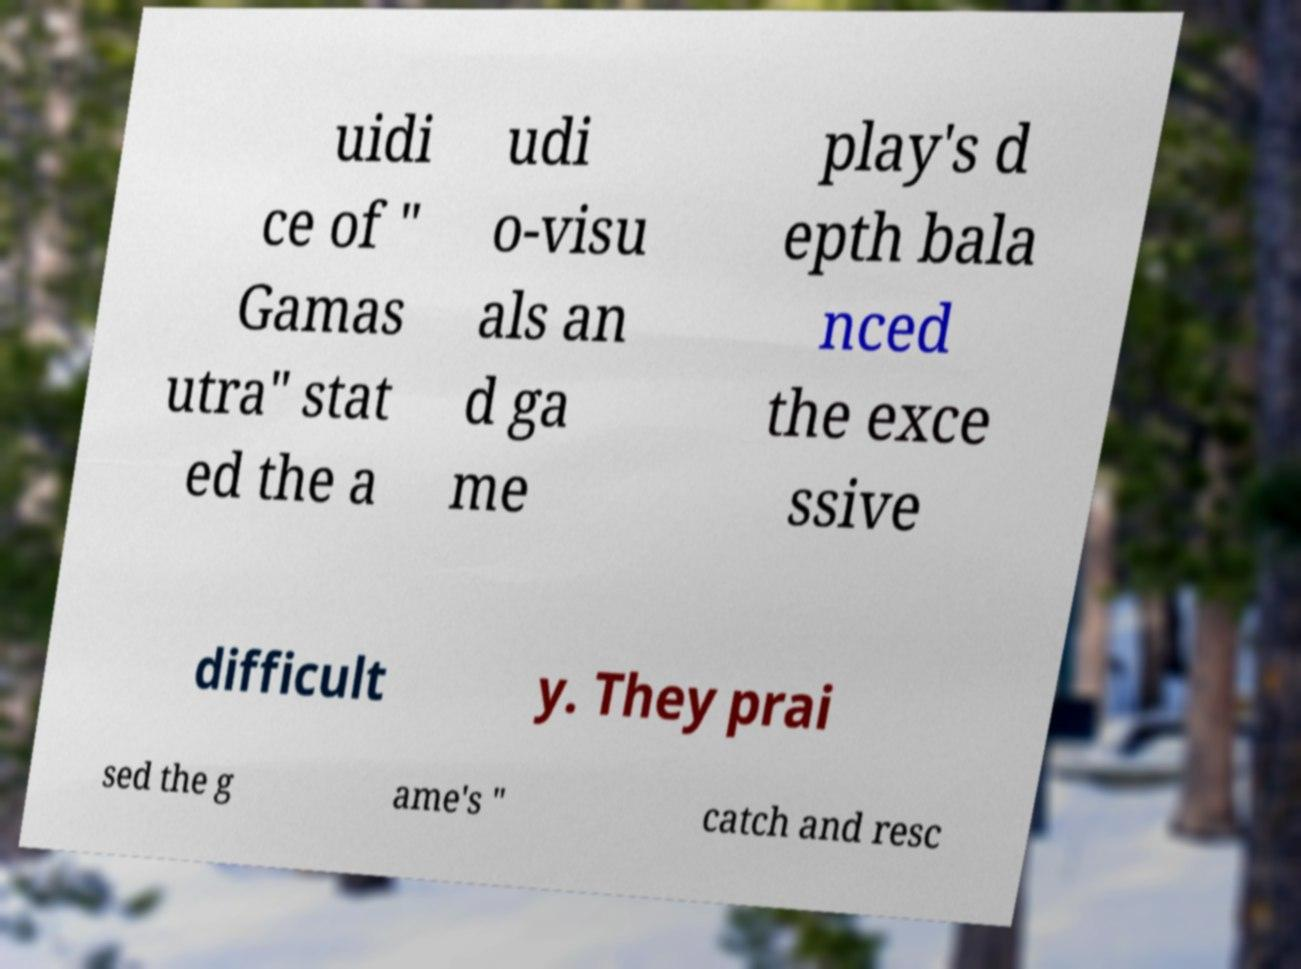Please read and relay the text visible in this image. What does it say? uidi ce of " Gamas utra" stat ed the a udi o-visu als an d ga me play's d epth bala nced the exce ssive difficult y. They prai sed the g ame's " catch and resc 